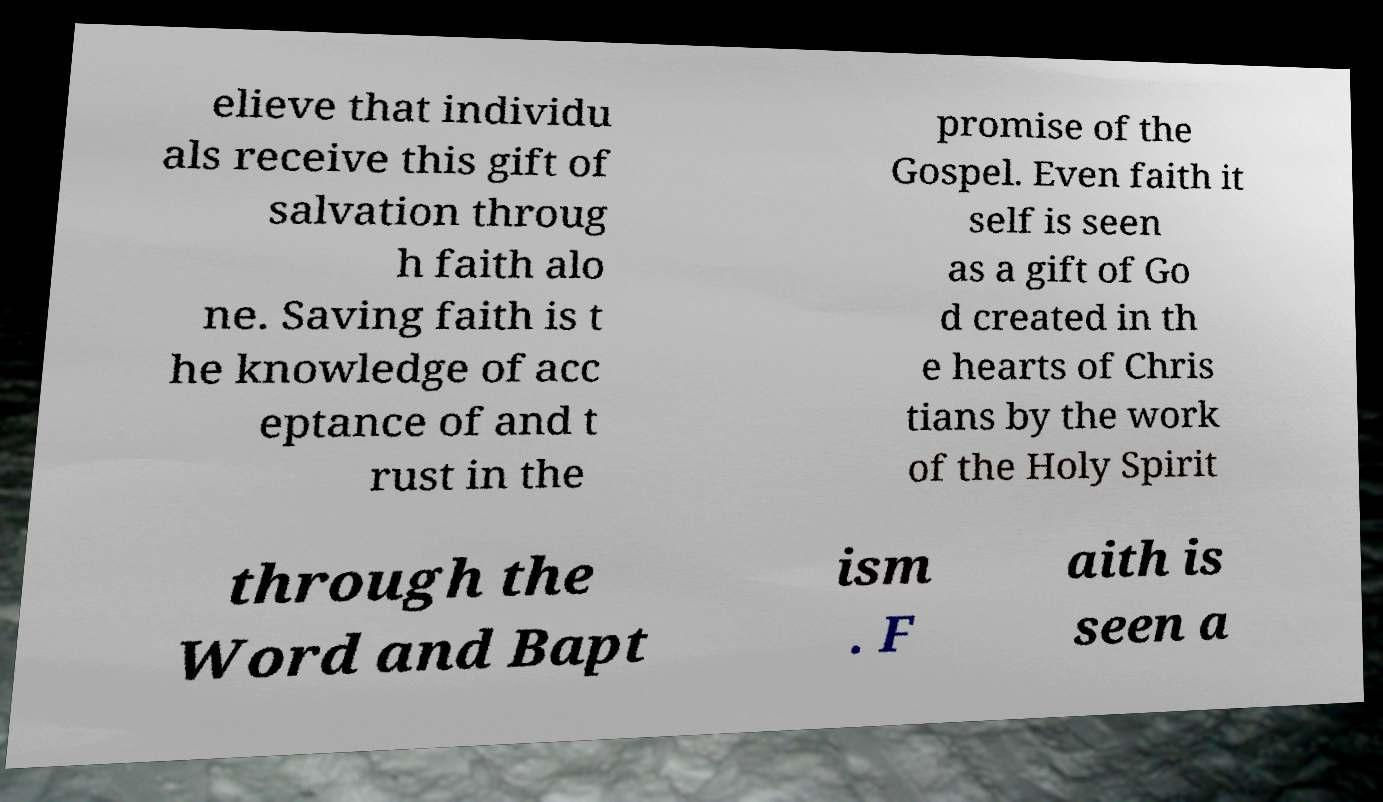For documentation purposes, I need the text within this image transcribed. Could you provide that? elieve that individu als receive this gift of salvation throug h faith alo ne. Saving faith is t he knowledge of acc eptance of and t rust in the promise of the Gospel. Even faith it self is seen as a gift of Go d created in th e hearts of Chris tians by the work of the Holy Spirit through the Word and Bapt ism . F aith is seen a 